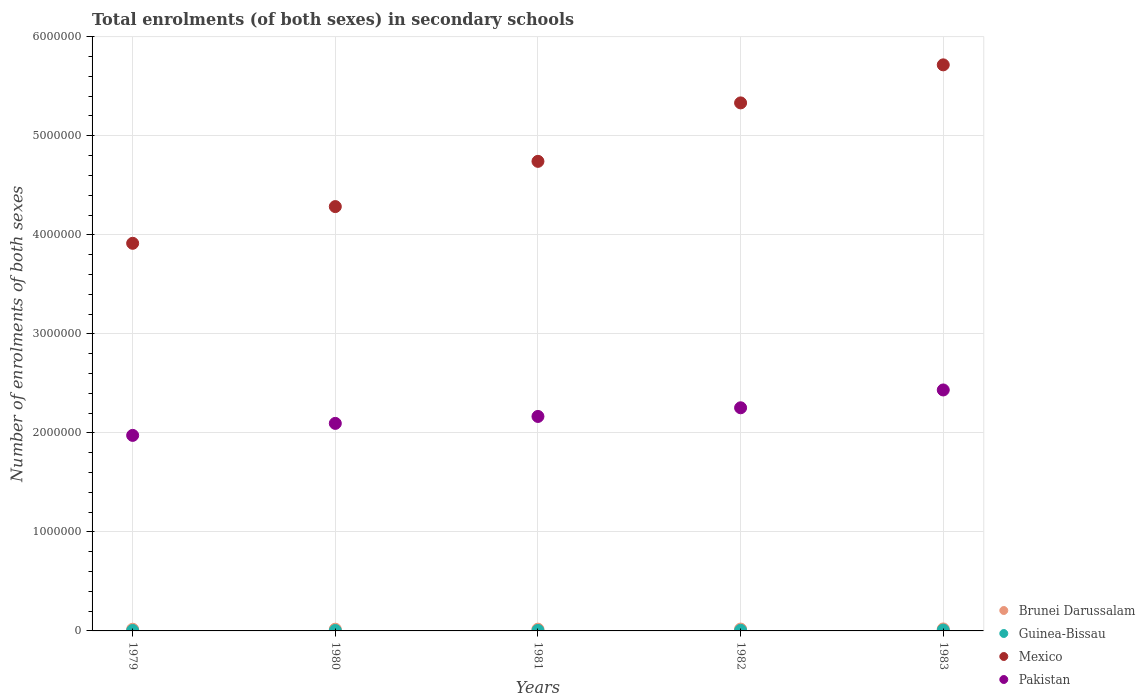How many different coloured dotlines are there?
Make the answer very short. 4. What is the number of enrolments in secondary schools in Mexico in 1981?
Provide a short and direct response. 4.74e+06. Across all years, what is the maximum number of enrolments in secondary schools in Guinea-Bissau?
Make the answer very short. 8432. Across all years, what is the minimum number of enrolments in secondary schools in Mexico?
Your answer should be compact. 3.91e+06. In which year was the number of enrolments in secondary schools in Pakistan maximum?
Your answer should be compact. 1983. In which year was the number of enrolments in secondary schools in Mexico minimum?
Your answer should be very brief. 1979. What is the total number of enrolments in secondary schools in Brunei Darussalam in the graph?
Offer a very short reply. 9.09e+04. What is the difference between the number of enrolments in secondary schools in Brunei Darussalam in 1979 and that in 1982?
Give a very brief answer. -1843. What is the difference between the number of enrolments in secondary schools in Pakistan in 1983 and the number of enrolments in secondary schools in Brunei Darussalam in 1981?
Ensure brevity in your answer.  2.42e+06. What is the average number of enrolments in secondary schools in Brunei Darussalam per year?
Provide a short and direct response. 1.82e+04. In the year 1982, what is the difference between the number of enrolments in secondary schools in Pakistan and number of enrolments in secondary schools in Guinea-Bissau?
Provide a succinct answer. 2.25e+06. In how many years, is the number of enrolments in secondary schools in Guinea-Bissau greater than 2400000?
Offer a terse response. 0. What is the ratio of the number of enrolments in secondary schools in Brunei Darussalam in 1979 to that in 1982?
Your answer should be compact. 0.9. Is the number of enrolments in secondary schools in Guinea-Bissau in 1982 less than that in 1983?
Your response must be concise. Yes. What is the difference between the highest and the second highest number of enrolments in secondary schools in Pakistan?
Provide a succinct answer. 1.80e+05. What is the difference between the highest and the lowest number of enrolments in secondary schools in Pakistan?
Offer a terse response. 4.59e+05. Is the sum of the number of enrolments in secondary schools in Brunei Darussalam in 1979 and 1982 greater than the maximum number of enrolments in secondary schools in Pakistan across all years?
Provide a succinct answer. No. Is it the case that in every year, the sum of the number of enrolments in secondary schools in Mexico and number of enrolments in secondary schools in Brunei Darussalam  is greater than the sum of number of enrolments in secondary schools in Guinea-Bissau and number of enrolments in secondary schools in Pakistan?
Ensure brevity in your answer.  Yes. Is it the case that in every year, the sum of the number of enrolments in secondary schools in Guinea-Bissau and number of enrolments in secondary schools in Brunei Darussalam  is greater than the number of enrolments in secondary schools in Mexico?
Provide a short and direct response. No. Does the number of enrolments in secondary schools in Pakistan monotonically increase over the years?
Give a very brief answer. Yes. Is the number of enrolments in secondary schools in Guinea-Bissau strictly less than the number of enrolments in secondary schools in Brunei Darussalam over the years?
Ensure brevity in your answer.  Yes. Where does the legend appear in the graph?
Your answer should be compact. Bottom right. How many legend labels are there?
Provide a succinct answer. 4. How are the legend labels stacked?
Make the answer very short. Vertical. What is the title of the graph?
Keep it short and to the point. Total enrolments (of both sexes) in secondary schools. Does "Gabon" appear as one of the legend labels in the graph?
Ensure brevity in your answer.  No. What is the label or title of the X-axis?
Keep it short and to the point. Years. What is the label or title of the Y-axis?
Give a very brief answer. Number of enrolments of both sexes. What is the Number of enrolments of both sexes of Brunei Darussalam in 1979?
Your answer should be very brief. 1.69e+04. What is the Number of enrolments of both sexes of Guinea-Bissau in 1979?
Keep it short and to the point. 4290. What is the Number of enrolments of both sexes in Mexico in 1979?
Provide a short and direct response. 3.91e+06. What is the Number of enrolments of both sexes of Pakistan in 1979?
Your response must be concise. 1.97e+06. What is the Number of enrolments of both sexes in Brunei Darussalam in 1980?
Ensure brevity in your answer.  1.74e+04. What is the Number of enrolments of both sexes in Guinea-Bissau in 1980?
Ensure brevity in your answer.  4256. What is the Number of enrolments of both sexes in Mexico in 1980?
Provide a succinct answer. 4.29e+06. What is the Number of enrolments of both sexes in Pakistan in 1980?
Give a very brief answer. 2.10e+06. What is the Number of enrolments of both sexes of Brunei Darussalam in 1981?
Your answer should be compact. 1.79e+04. What is the Number of enrolments of both sexes in Guinea-Bissau in 1981?
Ensure brevity in your answer.  4757. What is the Number of enrolments of both sexes in Mexico in 1981?
Offer a terse response. 4.74e+06. What is the Number of enrolments of both sexes of Pakistan in 1981?
Make the answer very short. 2.17e+06. What is the Number of enrolments of both sexes in Brunei Darussalam in 1982?
Ensure brevity in your answer.  1.87e+04. What is the Number of enrolments of both sexes in Guinea-Bissau in 1982?
Offer a very short reply. 6294. What is the Number of enrolments of both sexes of Mexico in 1982?
Give a very brief answer. 5.33e+06. What is the Number of enrolments of both sexes of Pakistan in 1982?
Offer a terse response. 2.25e+06. What is the Number of enrolments of both sexes of Brunei Darussalam in 1983?
Provide a succinct answer. 1.99e+04. What is the Number of enrolments of both sexes in Guinea-Bissau in 1983?
Ensure brevity in your answer.  8432. What is the Number of enrolments of both sexes in Mexico in 1983?
Your response must be concise. 5.72e+06. What is the Number of enrolments of both sexes in Pakistan in 1983?
Provide a succinct answer. 2.43e+06. Across all years, what is the maximum Number of enrolments of both sexes in Brunei Darussalam?
Provide a succinct answer. 1.99e+04. Across all years, what is the maximum Number of enrolments of both sexes in Guinea-Bissau?
Offer a very short reply. 8432. Across all years, what is the maximum Number of enrolments of both sexes in Mexico?
Your response must be concise. 5.72e+06. Across all years, what is the maximum Number of enrolments of both sexes in Pakistan?
Your answer should be compact. 2.43e+06. Across all years, what is the minimum Number of enrolments of both sexes of Brunei Darussalam?
Your response must be concise. 1.69e+04. Across all years, what is the minimum Number of enrolments of both sexes of Guinea-Bissau?
Ensure brevity in your answer.  4256. Across all years, what is the minimum Number of enrolments of both sexes in Mexico?
Offer a very short reply. 3.91e+06. Across all years, what is the minimum Number of enrolments of both sexes of Pakistan?
Ensure brevity in your answer.  1.97e+06. What is the total Number of enrolments of both sexes in Brunei Darussalam in the graph?
Give a very brief answer. 9.09e+04. What is the total Number of enrolments of both sexes in Guinea-Bissau in the graph?
Your answer should be compact. 2.80e+04. What is the total Number of enrolments of both sexes in Mexico in the graph?
Offer a very short reply. 2.40e+07. What is the total Number of enrolments of both sexes of Pakistan in the graph?
Give a very brief answer. 1.09e+07. What is the difference between the Number of enrolments of both sexes in Brunei Darussalam in 1979 and that in 1980?
Offer a very short reply. -550. What is the difference between the Number of enrolments of both sexes in Mexico in 1979 and that in 1980?
Your answer should be compact. -3.71e+05. What is the difference between the Number of enrolments of both sexes in Pakistan in 1979 and that in 1980?
Make the answer very short. -1.21e+05. What is the difference between the Number of enrolments of both sexes in Brunei Darussalam in 1979 and that in 1981?
Keep it short and to the point. -978. What is the difference between the Number of enrolments of both sexes in Guinea-Bissau in 1979 and that in 1981?
Ensure brevity in your answer.  -467. What is the difference between the Number of enrolments of both sexes in Mexico in 1979 and that in 1981?
Offer a very short reply. -8.28e+05. What is the difference between the Number of enrolments of both sexes of Pakistan in 1979 and that in 1981?
Your answer should be very brief. -1.91e+05. What is the difference between the Number of enrolments of both sexes of Brunei Darussalam in 1979 and that in 1982?
Your response must be concise. -1843. What is the difference between the Number of enrolments of both sexes in Guinea-Bissau in 1979 and that in 1982?
Offer a very short reply. -2004. What is the difference between the Number of enrolments of both sexes in Mexico in 1979 and that in 1982?
Your answer should be very brief. -1.42e+06. What is the difference between the Number of enrolments of both sexes of Pakistan in 1979 and that in 1982?
Keep it short and to the point. -2.79e+05. What is the difference between the Number of enrolments of both sexes of Brunei Darussalam in 1979 and that in 1983?
Make the answer very short. -3049. What is the difference between the Number of enrolments of both sexes of Guinea-Bissau in 1979 and that in 1983?
Ensure brevity in your answer.  -4142. What is the difference between the Number of enrolments of both sexes in Mexico in 1979 and that in 1983?
Keep it short and to the point. -1.80e+06. What is the difference between the Number of enrolments of both sexes of Pakistan in 1979 and that in 1983?
Offer a terse response. -4.59e+05. What is the difference between the Number of enrolments of both sexes of Brunei Darussalam in 1980 and that in 1981?
Provide a short and direct response. -428. What is the difference between the Number of enrolments of both sexes of Guinea-Bissau in 1980 and that in 1981?
Ensure brevity in your answer.  -501. What is the difference between the Number of enrolments of both sexes of Mexico in 1980 and that in 1981?
Keep it short and to the point. -4.57e+05. What is the difference between the Number of enrolments of both sexes in Pakistan in 1980 and that in 1981?
Ensure brevity in your answer.  -7.00e+04. What is the difference between the Number of enrolments of both sexes in Brunei Darussalam in 1980 and that in 1982?
Make the answer very short. -1293. What is the difference between the Number of enrolments of both sexes in Guinea-Bissau in 1980 and that in 1982?
Make the answer very short. -2038. What is the difference between the Number of enrolments of both sexes of Mexico in 1980 and that in 1982?
Provide a succinct answer. -1.05e+06. What is the difference between the Number of enrolments of both sexes in Pakistan in 1980 and that in 1982?
Make the answer very short. -1.58e+05. What is the difference between the Number of enrolments of both sexes of Brunei Darussalam in 1980 and that in 1983?
Offer a terse response. -2499. What is the difference between the Number of enrolments of both sexes in Guinea-Bissau in 1980 and that in 1983?
Ensure brevity in your answer.  -4176. What is the difference between the Number of enrolments of both sexes of Mexico in 1980 and that in 1983?
Your answer should be compact. -1.43e+06. What is the difference between the Number of enrolments of both sexes of Pakistan in 1980 and that in 1983?
Provide a succinct answer. -3.37e+05. What is the difference between the Number of enrolments of both sexes in Brunei Darussalam in 1981 and that in 1982?
Your answer should be very brief. -865. What is the difference between the Number of enrolments of both sexes in Guinea-Bissau in 1981 and that in 1982?
Ensure brevity in your answer.  -1537. What is the difference between the Number of enrolments of both sexes of Mexico in 1981 and that in 1982?
Provide a succinct answer. -5.90e+05. What is the difference between the Number of enrolments of both sexes of Pakistan in 1981 and that in 1982?
Your response must be concise. -8.75e+04. What is the difference between the Number of enrolments of both sexes of Brunei Darussalam in 1981 and that in 1983?
Keep it short and to the point. -2071. What is the difference between the Number of enrolments of both sexes of Guinea-Bissau in 1981 and that in 1983?
Provide a succinct answer. -3675. What is the difference between the Number of enrolments of both sexes of Mexico in 1981 and that in 1983?
Your answer should be compact. -9.74e+05. What is the difference between the Number of enrolments of both sexes in Pakistan in 1981 and that in 1983?
Your answer should be very brief. -2.67e+05. What is the difference between the Number of enrolments of both sexes in Brunei Darussalam in 1982 and that in 1983?
Make the answer very short. -1206. What is the difference between the Number of enrolments of both sexes of Guinea-Bissau in 1982 and that in 1983?
Your answer should be compact. -2138. What is the difference between the Number of enrolments of both sexes in Mexico in 1982 and that in 1983?
Your answer should be very brief. -3.84e+05. What is the difference between the Number of enrolments of both sexes in Pakistan in 1982 and that in 1983?
Keep it short and to the point. -1.80e+05. What is the difference between the Number of enrolments of both sexes of Brunei Darussalam in 1979 and the Number of enrolments of both sexes of Guinea-Bissau in 1980?
Provide a short and direct response. 1.26e+04. What is the difference between the Number of enrolments of both sexes of Brunei Darussalam in 1979 and the Number of enrolments of both sexes of Mexico in 1980?
Your answer should be very brief. -4.27e+06. What is the difference between the Number of enrolments of both sexes in Brunei Darussalam in 1979 and the Number of enrolments of both sexes in Pakistan in 1980?
Your answer should be very brief. -2.08e+06. What is the difference between the Number of enrolments of both sexes of Guinea-Bissau in 1979 and the Number of enrolments of both sexes of Mexico in 1980?
Provide a short and direct response. -4.28e+06. What is the difference between the Number of enrolments of both sexes of Guinea-Bissau in 1979 and the Number of enrolments of both sexes of Pakistan in 1980?
Your answer should be compact. -2.09e+06. What is the difference between the Number of enrolments of both sexes of Mexico in 1979 and the Number of enrolments of both sexes of Pakistan in 1980?
Keep it short and to the point. 1.82e+06. What is the difference between the Number of enrolments of both sexes of Brunei Darussalam in 1979 and the Number of enrolments of both sexes of Guinea-Bissau in 1981?
Make the answer very short. 1.21e+04. What is the difference between the Number of enrolments of both sexes in Brunei Darussalam in 1979 and the Number of enrolments of both sexes in Mexico in 1981?
Your answer should be compact. -4.72e+06. What is the difference between the Number of enrolments of both sexes in Brunei Darussalam in 1979 and the Number of enrolments of both sexes in Pakistan in 1981?
Offer a terse response. -2.15e+06. What is the difference between the Number of enrolments of both sexes of Guinea-Bissau in 1979 and the Number of enrolments of both sexes of Mexico in 1981?
Your answer should be very brief. -4.74e+06. What is the difference between the Number of enrolments of both sexes of Guinea-Bissau in 1979 and the Number of enrolments of both sexes of Pakistan in 1981?
Make the answer very short. -2.16e+06. What is the difference between the Number of enrolments of both sexes in Mexico in 1979 and the Number of enrolments of both sexes in Pakistan in 1981?
Make the answer very short. 1.75e+06. What is the difference between the Number of enrolments of both sexes of Brunei Darussalam in 1979 and the Number of enrolments of both sexes of Guinea-Bissau in 1982?
Offer a terse response. 1.06e+04. What is the difference between the Number of enrolments of both sexes of Brunei Darussalam in 1979 and the Number of enrolments of both sexes of Mexico in 1982?
Keep it short and to the point. -5.32e+06. What is the difference between the Number of enrolments of both sexes of Brunei Darussalam in 1979 and the Number of enrolments of both sexes of Pakistan in 1982?
Provide a short and direct response. -2.24e+06. What is the difference between the Number of enrolments of both sexes of Guinea-Bissau in 1979 and the Number of enrolments of both sexes of Mexico in 1982?
Ensure brevity in your answer.  -5.33e+06. What is the difference between the Number of enrolments of both sexes in Guinea-Bissau in 1979 and the Number of enrolments of both sexes in Pakistan in 1982?
Provide a succinct answer. -2.25e+06. What is the difference between the Number of enrolments of both sexes in Mexico in 1979 and the Number of enrolments of both sexes in Pakistan in 1982?
Make the answer very short. 1.66e+06. What is the difference between the Number of enrolments of both sexes in Brunei Darussalam in 1979 and the Number of enrolments of both sexes in Guinea-Bissau in 1983?
Provide a succinct answer. 8459. What is the difference between the Number of enrolments of both sexes of Brunei Darussalam in 1979 and the Number of enrolments of both sexes of Mexico in 1983?
Offer a very short reply. -5.70e+06. What is the difference between the Number of enrolments of both sexes in Brunei Darussalam in 1979 and the Number of enrolments of both sexes in Pakistan in 1983?
Give a very brief answer. -2.42e+06. What is the difference between the Number of enrolments of both sexes in Guinea-Bissau in 1979 and the Number of enrolments of both sexes in Mexico in 1983?
Offer a terse response. -5.71e+06. What is the difference between the Number of enrolments of both sexes in Guinea-Bissau in 1979 and the Number of enrolments of both sexes in Pakistan in 1983?
Your response must be concise. -2.43e+06. What is the difference between the Number of enrolments of both sexes in Mexico in 1979 and the Number of enrolments of both sexes in Pakistan in 1983?
Provide a short and direct response. 1.48e+06. What is the difference between the Number of enrolments of both sexes in Brunei Darussalam in 1980 and the Number of enrolments of both sexes in Guinea-Bissau in 1981?
Give a very brief answer. 1.27e+04. What is the difference between the Number of enrolments of both sexes of Brunei Darussalam in 1980 and the Number of enrolments of both sexes of Mexico in 1981?
Offer a very short reply. -4.72e+06. What is the difference between the Number of enrolments of both sexes in Brunei Darussalam in 1980 and the Number of enrolments of both sexes in Pakistan in 1981?
Ensure brevity in your answer.  -2.15e+06. What is the difference between the Number of enrolments of both sexes of Guinea-Bissau in 1980 and the Number of enrolments of both sexes of Mexico in 1981?
Your answer should be compact. -4.74e+06. What is the difference between the Number of enrolments of both sexes in Guinea-Bissau in 1980 and the Number of enrolments of both sexes in Pakistan in 1981?
Your response must be concise. -2.16e+06. What is the difference between the Number of enrolments of both sexes of Mexico in 1980 and the Number of enrolments of both sexes of Pakistan in 1981?
Provide a succinct answer. 2.12e+06. What is the difference between the Number of enrolments of both sexes of Brunei Darussalam in 1980 and the Number of enrolments of both sexes of Guinea-Bissau in 1982?
Offer a very short reply. 1.11e+04. What is the difference between the Number of enrolments of both sexes in Brunei Darussalam in 1980 and the Number of enrolments of both sexes in Mexico in 1982?
Keep it short and to the point. -5.31e+06. What is the difference between the Number of enrolments of both sexes of Brunei Darussalam in 1980 and the Number of enrolments of both sexes of Pakistan in 1982?
Your answer should be very brief. -2.24e+06. What is the difference between the Number of enrolments of both sexes of Guinea-Bissau in 1980 and the Number of enrolments of both sexes of Mexico in 1982?
Give a very brief answer. -5.33e+06. What is the difference between the Number of enrolments of both sexes in Guinea-Bissau in 1980 and the Number of enrolments of both sexes in Pakistan in 1982?
Offer a terse response. -2.25e+06. What is the difference between the Number of enrolments of both sexes of Mexico in 1980 and the Number of enrolments of both sexes of Pakistan in 1982?
Your response must be concise. 2.03e+06. What is the difference between the Number of enrolments of both sexes in Brunei Darussalam in 1980 and the Number of enrolments of both sexes in Guinea-Bissau in 1983?
Your answer should be very brief. 9009. What is the difference between the Number of enrolments of both sexes of Brunei Darussalam in 1980 and the Number of enrolments of both sexes of Mexico in 1983?
Provide a succinct answer. -5.70e+06. What is the difference between the Number of enrolments of both sexes of Brunei Darussalam in 1980 and the Number of enrolments of both sexes of Pakistan in 1983?
Your answer should be compact. -2.42e+06. What is the difference between the Number of enrolments of both sexes in Guinea-Bissau in 1980 and the Number of enrolments of both sexes in Mexico in 1983?
Your response must be concise. -5.71e+06. What is the difference between the Number of enrolments of both sexes in Guinea-Bissau in 1980 and the Number of enrolments of both sexes in Pakistan in 1983?
Provide a succinct answer. -2.43e+06. What is the difference between the Number of enrolments of both sexes in Mexico in 1980 and the Number of enrolments of both sexes in Pakistan in 1983?
Provide a succinct answer. 1.85e+06. What is the difference between the Number of enrolments of both sexes in Brunei Darussalam in 1981 and the Number of enrolments of both sexes in Guinea-Bissau in 1982?
Keep it short and to the point. 1.16e+04. What is the difference between the Number of enrolments of both sexes of Brunei Darussalam in 1981 and the Number of enrolments of both sexes of Mexico in 1982?
Your answer should be compact. -5.31e+06. What is the difference between the Number of enrolments of both sexes of Brunei Darussalam in 1981 and the Number of enrolments of both sexes of Pakistan in 1982?
Your answer should be very brief. -2.24e+06. What is the difference between the Number of enrolments of both sexes in Guinea-Bissau in 1981 and the Number of enrolments of both sexes in Mexico in 1982?
Your answer should be very brief. -5.33e+06. What is the difference between the Number of enrolments of both sexes of Guinea-Bissau in 1981 and the Number of enrolments of both sexes of Pakistan in 1982?
Your answer should be very brief. -2.25e+06. What is the difference between the Number of enrolments of both sexes of Mexico in 1981 and the Number of enrolments of both sexes of Pakistan in 1982?
Offer a terse response. 2.49e+06. What is the difference between the Number of enrolments of both sexes in Brunei Darussalam in 1981 and the Number of enrolments of both sexes in Guinea-Bissau in 1983?
Provide a succinct answer. 9437. What is the difference between the Number of enrolments of both sexes in Brunei Darussalam in 1981 and the Number of enrolments of both sexes in Mexico in 1983?
Ensure brevity in your answer.  -5.70e+06. What is the difference between the Number of enrolments of both sexes of Brunei Darussalam in 1981 and the Number of enrolments of both sexes of Pakistan in 1983?
Your response must be concise. -2.42e+06. What is the difference between the Number of enrolments of both sexes of Guinea-Bissau in 1981 and the Number of enrolments of both sexes of Mexico in 1983?
Provide a short and direct response. -5.71e+06. What is the difference between the Number of enrolments of both sexes in Guinea-Bissau in 1981 and the Number of enrolments of both sexes in Pakistan in 1983?
Ensure brevity in your answer.  -2.43e+06. What is the difference between the Number of enrolments of both sexes in Mexico in 1981 and the Number of enrolments of both sexes in Pakistan in 1983?
Keep it short and to the point. 2.31e+06. What is the difference between the Number of enrolments of both sexes in Brunei Darussalam in 1982 and the Number of enrolments of both sexes in Guinea-Bissau in 1983?
Your answer should be very brief. 1.03e+04. What is the difference between the Number of enrolments of both sexes of Brunei Darussalam in 1982 and the Number of enrolments of both sexes of Mexico in 1983?
Your answer should be very brief. -5.70e+06. What is the difference between the Number of enrolments of both sexes of Brunei Darussalam in 1982 and the Number of enrolments of both sexes of Pakistan in 1983?
Offer a terse response. -2.41e+06. What is the difference between the Number of enrolments of both sexes of Guinea-Bissau in 1982 and the Number of enrolments of both sexes of Mexico in 1983?
Provide a succinct answer. -5.71e+06. What is the difference between the Number of enrolments of both sexes of Guinea-Bissau in 1982 and the Number of enrolments of both sexes of Pakistan in 1983?
Your answer should be compact. -2.43e+06. What is the difference between the Number of enrolments of both sexes in Mexico in 1982 and the Number of enrolments of both sexes in Pakistan in 1983?
Your answer should be very brief. 2.90e+06. What is the average Number of enrolments of both sexes of Brunei Darussalam per year?
Offer a terse response. 1.82e+04. What is the average Number of enrolments of both sexes in Guinea-Bissau per year?
Provide a short and direct response. 5605.8. What is the average Number of enrolments of both sexes in Mexico per year?
Offer a very short reply. 4.80e+06. What is the average Number of enrolments of both sexes of Pakistan per year?
Give a very brief answer. 2.18e+06. In the year 1979, what is the difference between the Number of enrolments of both sexes in Brunei Darussalam and Number of enrolments of both sexes in Guinea-Bissau?
Ensure brevity in your answer.  1.26e+04. In the year 1979, what is the difference between the Number of enrolments of both sexes of Brunei Darussalam and Number of enrolments of both sexes of Mexico?
Provide a succinct answer. -3.90e+06. In the year 1979, what is the difference between the Number of enrolments of both sexes of Brunei Darussalam and Number of enrolments of both sexes of Pakistan?
Keep it short and to the point. -1.96e+06. In the year 1979, what is the difference between the Number of enrolments of both sexes of Guinea-Bissau and Number of enrolments of both sexes of Mexico?
Ensure brevity in your answer.  -3.91e+06. In the year 1979, what is the difference between the Number of enrolments of both sexes of Guinea-Bissau and Number of enrolments of both sexes of Pakistan?
Offer a terse response. -1.97e+06. In the year 1979, what is the difference between the Number of enrolments of both sexes in Mexico and Number of enrolments of both sexes in Pakistan?
Provide a succinct answer. 1.94e+06. In the year 1980, what is the difference between the Number of enrolments of both sexes in Brunei Darussalam and Number of enrolments of both sexes in Guinea-Bissau?
Make the answer very short. 1.32e+04. In the year 1980, what is the difference between the Number of enrolments of both sexes of Brunei Darussalam and Number of enrolments of both sexes of Mexico?
Give a very brief answer. -4.27e+06. In the year 1980, what is the difference between the Number of enrolments of both sexes of Brunei Darussalam and Number of enrolments of both sexes of Pakistan?
Provide a succinct answer. -2.08e+06. In the year 1980, what is the difference between the Number of enrolments of both sexes in Guinea-Bissau and Number of enrolments of both sexes in Mexico?
Offer a terse response. -4.28e+06. In the year 1980, what is the difference between the Number of enrolments of both sexes in Guinea-Bissau and Number of enrolments of both sexes in Pakistan?
Your answer should be very brief. -2.09e+06. In the year 1980, what is the difference between the Number of enrolments of both sexes of Mexico and Number of enrolments of both sexes of Pakistan?
Give a very brief answer. 2.19e+06. In the year 1981, what is the difference between the Number of enrolments of both sexes in Brunei Darussalam and Number of enrolments of both sexes in Guinea-Bissau?
Make the answer very short. 1.31e+04. In the year 1981, what is the difference between the Number of enrolments of both sexes of Brunei Darussalam and Number of enrolments of both sexes of Mexico?
Provide a short and direct response. -4.72e+06. In the year 1981, what is the difference between the Number of enrolments of both sexes in Brunei Darussalam and Number of enrolments of both sexes in Pakistan?
Give a very brief answer. -2.15e+06. In the year 1981, what is the difference between the Number of enrolments of both sexes in Guinea-Bissau and Number of enrolments of both sexes in Mexico?
Provide a short and direct response. -4.74e+06. In the year 1981, what is the difference between the Number of enrolments of both sexes in Guinea-Bissau and Number of enrolments of both sexes in Pakistan?
Your answer should be very brief. -2.16e+06. In the year 1981, what is the difference between the Number of enrolments of both sexes of Mexico and Number of enrolments of both sexes of Pakistan?
Your response must be concise. 2.58e+06. In the year 1982, what is the difference between the Number of enrolments of both sexes of Brunei Darussalam and Number of enrolments of both sexes of Guinea-Bissau?
Provide a succinct answer. 1.24e+04. In the year 1982, what is the difference between the Number of enrolments of both sexes in Brunei Darussalam and Number of enrolments of both sexes in Mexico?
Make the answer very short. -5.31e+06. In the year 1982, what is the difference between the Number of enrolments of both sexes of Brunei Darussalam and Number of enrolments of both sexes of Pakistan?
Offer a very short reply. -2.23e+06. In the year 1982, what is the difference between the Number of enrolments of both sexes in Guinea-Bissau and Number of enrolments of both sexes in Mexico?
Your answer should be compact. -5.33e+06. In the year 1982, what is the difference between the Number of enrolments of both sexes of Guinea-Bissau and Number of enrolments of both sexes of Pakistan?
Make the answer very short. -2.25e+06. In the year 1982, what is the difference between the Number of enrolments of both sexes in Mexico and Number of enrolments of both sexes in Pakistan?
Ensure brevity in your answer.  3.08e+06. In the year 1983, what is the difference between the Number of enrolments of both sexes in Brunei Darussalam and Number of enrolments of both sexes in Guinea-Bissau?
Ensure brevity in your answer.  1.15e+04. In the year 1983, what is the difference between the Number of enrolments of both sexes of Brunei Darussalam and Number of enrolments of both sexes of Mexico?
Keep it short and to the point. -5.70e+06. In the year 1983, what is the difference between the Number of enrolments of both sexes in Brunei Darussalam and Number of enrolments of both sexes in Pakistan?
Make the answer very short. -2.41e+06. In the year 1983, what is the difference between the Number of enrolments of both sexes in Guinea-Bissau and Number of enrolments of both sexes in Mexico?
Provide a succinct answer. -5.71e+06. In the year 1983, what is the difference between the Number of enrolments of both sexes in Guinea-Bissau and Number of enrolments of both sexes in Pakistan?
Keep it short and to the point. -2.42e+06. In the year 1983, what is the difference between the Number of enrolments of both sexes in Mexico and Number of enrolments of both sexes in Pakistan?
Give a very brief answer. 3.28e+06. What is the ratio of the Number of enrolments of both sexes of Brunei Darussalam in 1979 to that in 1980?
Your response must be concise. 0.97. What is the ratio of the Number of enrolments of both sexes in Mexico in 1979 to that in 1980?
Offer a very short reply. 0.91. What is the ratio of the Number of enrolments of both sexes of Pakistan in 1979 to that in 1980?
Your answer should be very brief. 0.94. What is the ratio of the Number of enrolments of both sexes of Brunei Darussalam in 1979 to that in 1981?
Ensure brevity in your answer.  0.95. What is the ratio of the Number of enrolments of both sexes in Guinea-Bissau in 1979 to that in 1981?
Give a very brief answer. 0.9. What is the ratio of the Number of enrolments of both sexes in Mexico in 1979 to that in 1981?
Your response must be concise. 0.83. What is the ratio of the Number of enrolments of both sexes in Pakistan in 1979 to that in 1981?
Give a very brief answer. 0.91. What is the ratio of the Number of enrolments of both sexes in Brunei Darussalam in 1979 to that in 1982?
Keep it short and to the point. 0.9. What is the ratio of the Number of enrolments of both sexes in Guinea-Bissau in 1979 to that in 1982?
Your answer should be compact. 0.68. What is the ratio of the Number of enrolments of both sexes of Mexico in 1979 to that in 1982?
Your answer should be compact. 0.73. What is the ratio of the Number of enrolments of both sexes of Pakistan in 1979 to that in 1982?
Keep it short and to the point. 0.88. What is the ratio of the Number of enrolments of both sexes in Brunei Darussalam in 1979 to that in 1983?
Your answer should be compact. 0.85. What is the ratio of the Number of enrolments of both sexes of Guinea-Bissau in 1979 to that in 1983?
Your response must be concise. 0.51. What is the ratio of the Number of enrolments of both sexes of Mexico in 1979 to that in 1983?
Keep it short and to the point. 0.68. What is the ratio of the Number of enrolments of both sexes in Pakistan in 1979 to that in 1983?
Provide a succinct answer. 0.81. What is the ratio of the Number of enrolments of both sexes of Brunei Darussalam in 1980 to that in 1981?
Ensure brevity in your answer.  0.98. What is the ratio of the Number of enrolments of both sexes of Guinea-Bissau in 1980 to that in 1981?
Make the answer very short. 0.89. What is the ratio of the Number of enrolments of both sexes in Mexico in 1980 to that in 1981?
Provide a short and direct response. 0.9. What is the ratio of the Number of enrolments of both sexes of Guinea-Bissau in 1980 to that in 1982?
Your answer should be very brief. 0.68. What is the ratio of the Number of enrolments of both sexes in Mexico in 1980 to that in 1982?
Provide a succinct answer. 0.8. What is the ratio of the Number of enrolments of both sexes of Pakistan in 1980 to that in 1982?
Offer a very short reply. 0.93. What is the ratio of the Number of enrolments of both sexes of Brunei Darussalam in 1980 to that in 1983?
Your answer should be very brief. 0.87. What is the ratio of the Number of enrolments of both sexes in Guinea-Bissau in 1980 to that in 1983?
Your response must be concise. 0.5. What is the ratio of the Number of enrolments of both sexes of Mexico in 1980 to that in 1983?
Offer a terse response. 0.75. What is the ratio of the Number of enrolments of both sexes in Pakistan in 1980 to that in 1983?
Provide a short and direct response. 0.86. What is the ratio of the Number of enrolments of both sexes of Brunei Darussalam in 1981 to that in 1982?
Keep it short and to the point. 0.95. What is the ratio of the Number of enrolments of both sexes of Guinea-Bissau in 1981 to that in 1982?
Make the answer very short. 0.76. What is the ratio of the Number of enrolments of both sexes of Mexico in 1981 to that in 1982?
Your answer should be very brief. 0.89. What is the ratio of the Number of enrolments of both sexes of Pakistan in 1981 to that in 1982?
Offer a very short reply. 0.96. What is the ratio of the Number of enrolments of both sexes in Brunei Darussalam in 1981 to that in 1983?
Your answer should be very brief. 0.9. What is the ratio of the Number of enrolments of both sexes of Guinea-Bissau in 1981 to that in 1983?
Provide a short and direct response. 0.56. What is the ratio of the Number of enrolments of both sexes in Mexico in 1981 to that in 1983?
Your answer should be very brief. 0.83. What is the ratio of the Number of enrolments of both sexes of Pakistan in 1981 to that in 1983?
Provide a short and direct response. 0.89. What is the ratio of the Number of enrolments of both sexes of Brunei Darussalam in 1982 to that in 1983?
Your answer should be very brief. 0.94. What is the ratio of the Number of enrolments of both sexes of Guinea-Bissau in 1982 to that in 1983?
Ensure brevity in your answer.  0.75. What is the ratio of the Number of enrolments of both sexes in Mexico in 1982 to that in 1983?
Provide a succinct answer. 0.93. What is the ratio of the Number of enrolments of both sexes of Pakistan in 1982 to that in 1983?
Give a very brief answer. 0.93. What is the difference between the highest and the second highest Number of enrolments of both sexes in Brunei Darussalam?
Make the answer very short. 1206. What is the difference between the highest and the second highest Number of enrolments of both sexes in Guinea-Bissau?
Give a very brief answer. 2138. What is the difference between the highest and the second highest Number of enrolments of both sexes in Mexico?
Offer a terse response. 3.84e+05. What is the difference between the highest and the second highest Number of enrolments of both sexes of Pakistan?
Your response must be concise. 1.80e+05. What is the difference between the highest and the lowest Number of enrolments of both sexes of Brunei Darussalam?
Offer a terse response. 3049. What is the difference between the highest and the lowest Number of enrolments of both sexes of Guinea-Bissau?
Ensure brevity in your answer.  4176. What is the difference between the highest and the lowest Number of enrolments of both sexes in Mexico?
Provide a short and direct response. 1.80e+06. What is the difference between the highest and the lowest Number of enrolments of both sexes in Pakistan?
Your response must be concise. 4.59e+05. 